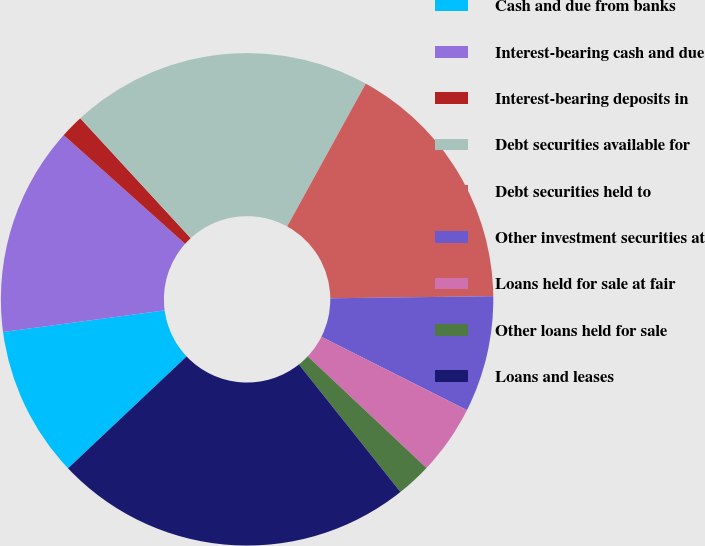Convert chart to OTSL. <chart><loc_0><loc_0><loc_500><loc_500><pie_chart><fcel>Cash and due from banks<fcel>Interest-bearing cash and due<fcel>Interest-bearing deposits in<fcel>Debt securities available for<fcel>Debt securities held to<fcel>Other investment securities at<fcel>Loans held for sale at fair<fcel>Other loans held for sale<fcel>Loans and leases<nl><fcel>9.92%<fcel>13.74%<fcel>1.53%<fcel>19.85%<fcel>16.79%<fcel>7.63%<fcel>4.58%<fcel>2.29%<fcel>23.66%<nl></chart> 